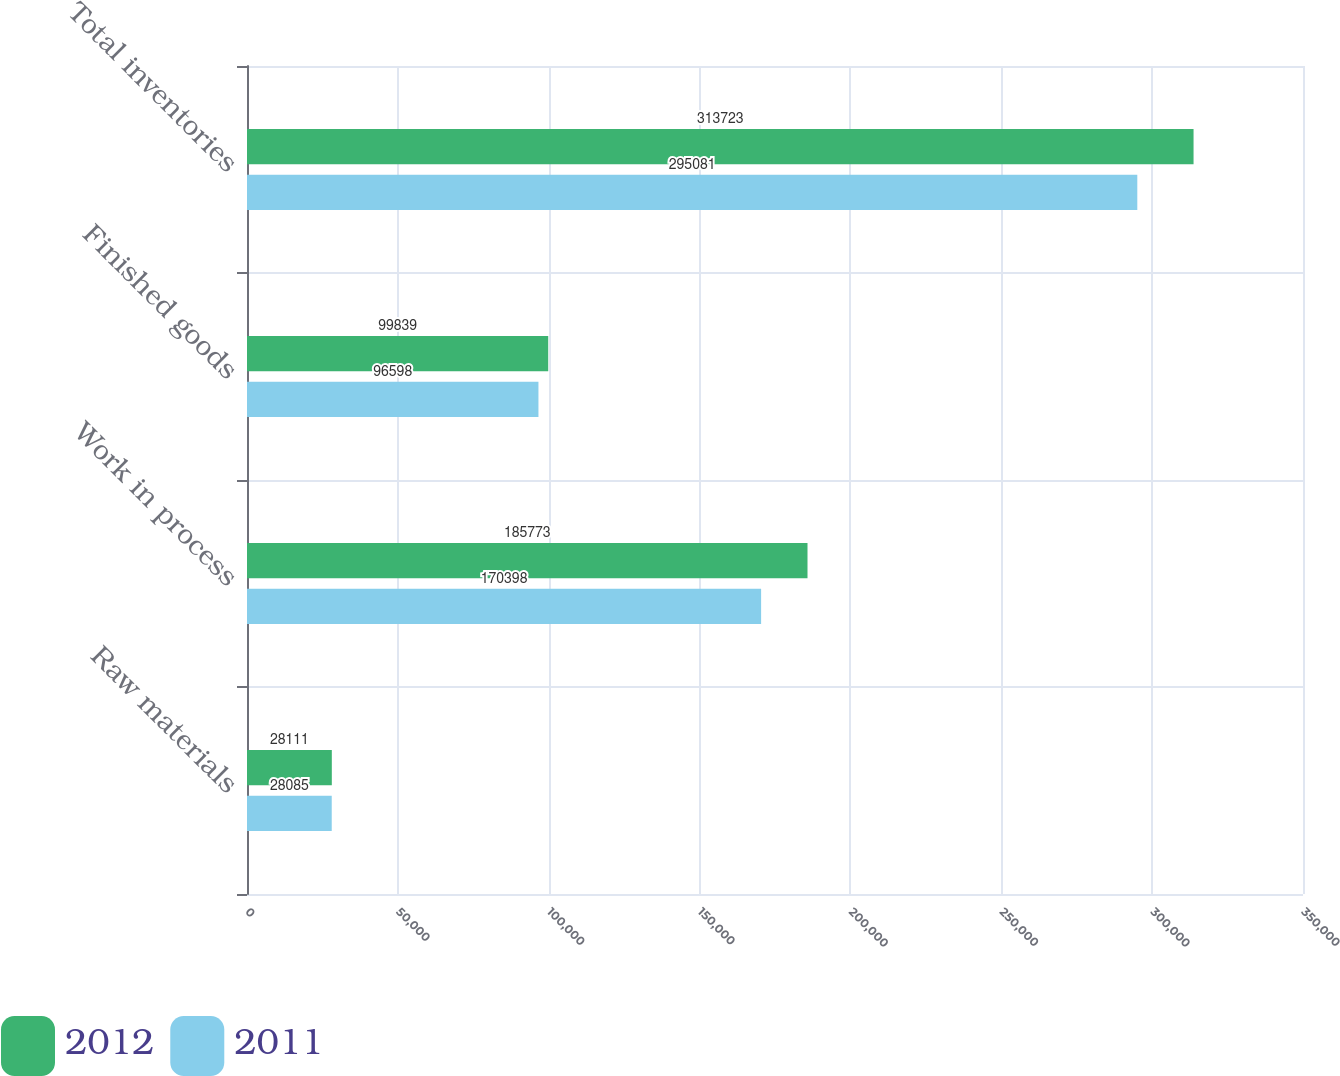Convert chart to OTSL. <chart><loc_0><loc_0><loc_500><loc_500><stacked_bar_chart><ecel><fcel>Raw materials<fcel>Work in process<fcel>Finished goods<fcel>Total inventories<nl><fcel>2012<fcel>28111<fcel>185773<fcel>99839<fcel>313723<nl><fcel>2011<fcel>28085<fcel>170398<fcel>96598<fcel>295081<nl></chart> 